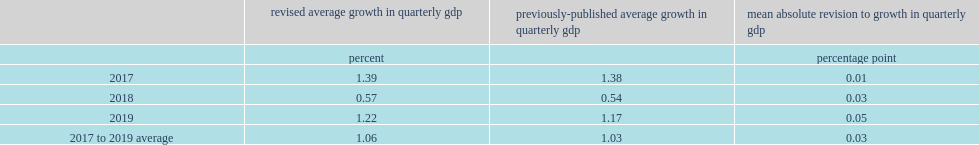What was the percentage point of the average upward revision as downward revisions in some quarters largely offset upward revisions in other quarters? 0.03. 